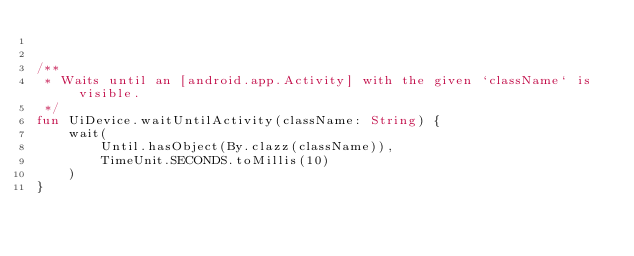Convert code to text. <code><loc_0><loc_0><loc_500><loc_500><_Kotlin_>

/**
 * Waits until an [android.app.Activity] with the given `className` is visible.
 */
fun UiDevice.waitUntilActivity(className: String) {
    wait(
        Until.hasObject(By.clazz(className)),
        TimeUnit.SECONDS.toMillis(10)
    )
}</code> 